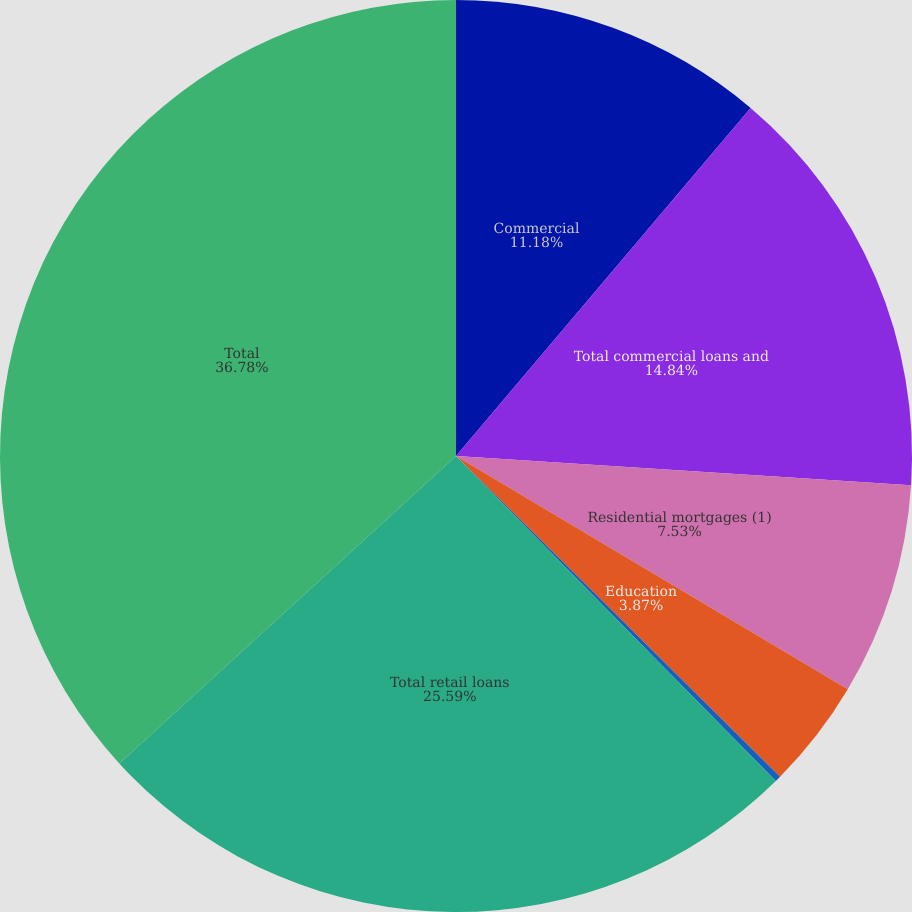<chart> <loc_0><loc_0><loc_500><loc_500><pie_chart><fcel>Commercial<fcel>Total commercial loans and<fcel>Residential mortgages (1)<fcel>Education<fcel>Other retail<fcel>Total retail loans<fcel>Total<nl><fcel>11.18%<fcel>14.84%<fcel>7.53%<fcel>3.87%<fcel>0.21%<fcel>25.59%<fcel>36.78%<nl></chart> 